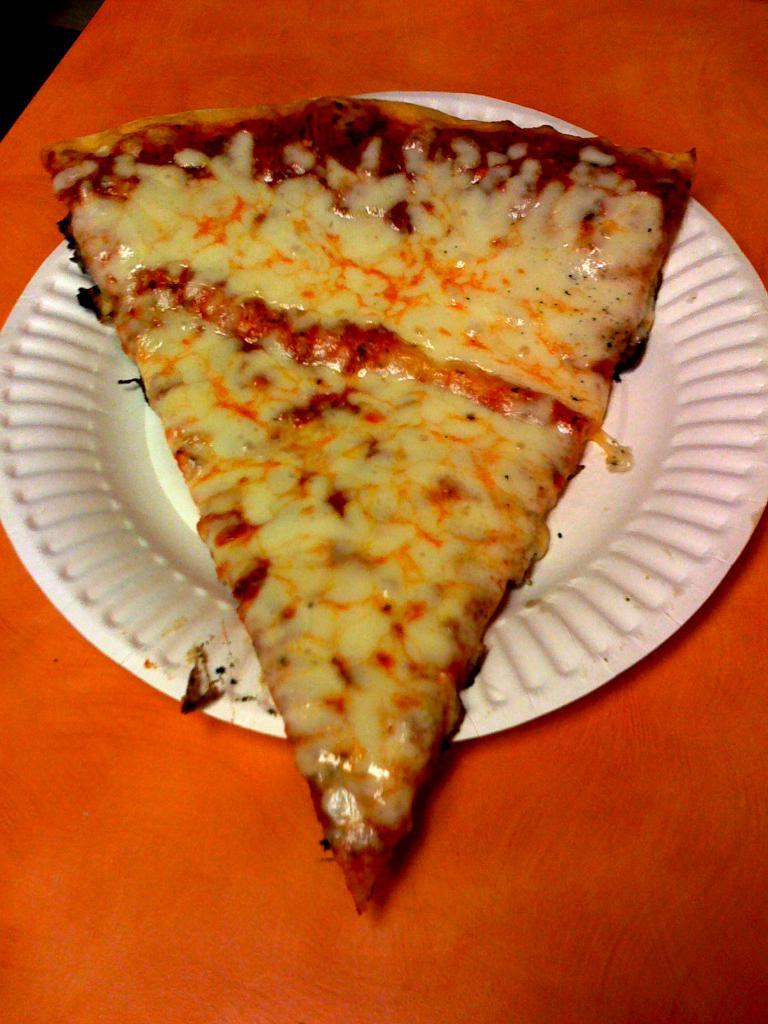What type of food is visible in the image? There is a pizza slice in the image. How is the pizza slice presented? The pizza slice is served on a plate. Where is the plate with the pizza slice located? The plate with the pizza slice is on a table. How many books are stacked on the pizza slice in the image? There are no books present in the image; it features a pizza slice served on a plate. 